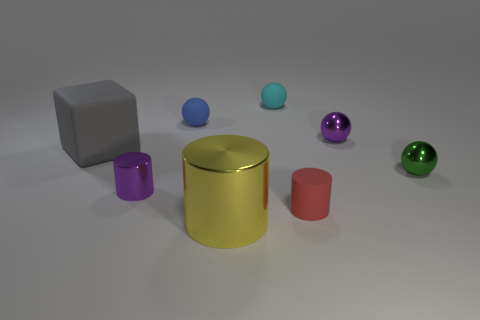Subtract all tiny cylinders. How many cylinders are left? 1 Add 1 small blue matte balls. How many objects exist? 9 Subtract all purple balls. How many balls are left? 3 Subtract 1 spheres. How many spheres are left? 3 Subtract all blocks. How many objects are left? 7 Subtract all small blue matte balls. Subtract all tiny balls. How many objects are left? 3 Add 5 cyan objects. How many cyan objects are left? 6 Add 3 cubes. How many cubes exist? 4 Subtract 0 cyan cubes. How many objects are left? 8 Subtract all gray cylinders. Subtract all brown balls. How many cylinders are left? 3 